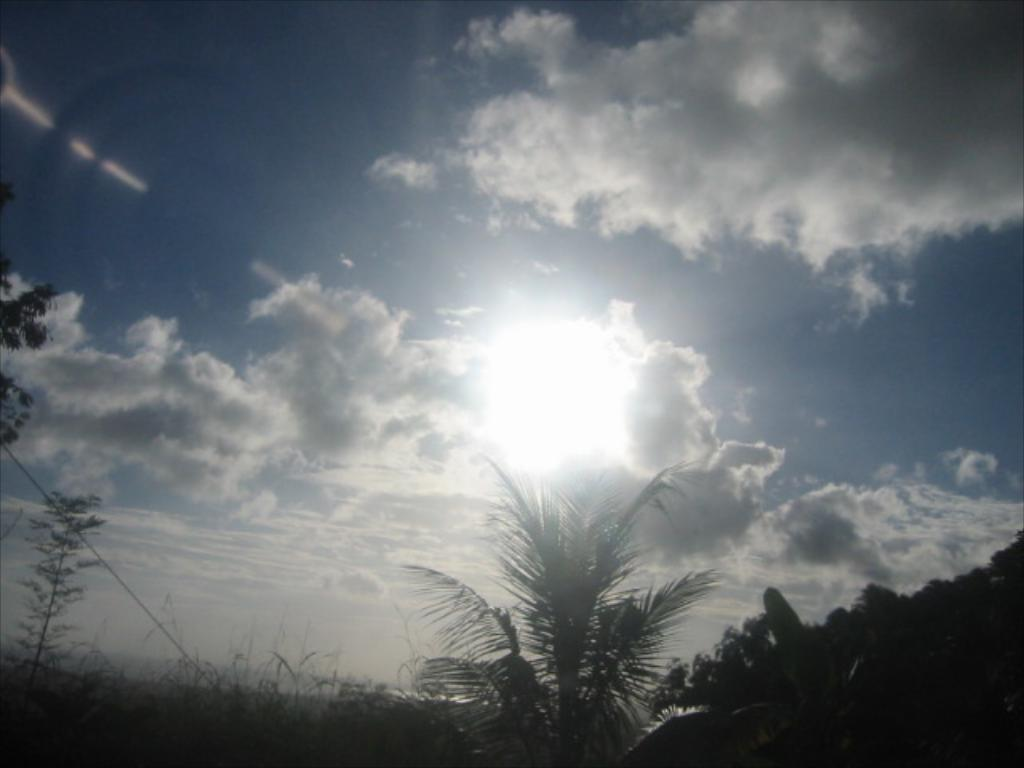What type of vegetation can be seen in the image? There are plants and trees in the image. What is visible in the background of the image? The sky is visible in the image. Can you describe the color of the sky in the image? The sky has a white and blue color in the image. How would you describe the weather based on the sky in the image? The sky is a bit cloudy in the image, suggesting partly cloudy weather. Is the sun visible in the image? Yes, the sun is visible in the image. What type of flesh can be seen on the trees in the image? There is no flesh present on the trees in the image; they are made of wood and leaves. What kind of brick structure can be seen in the image? There is no brick structure present in the image. 